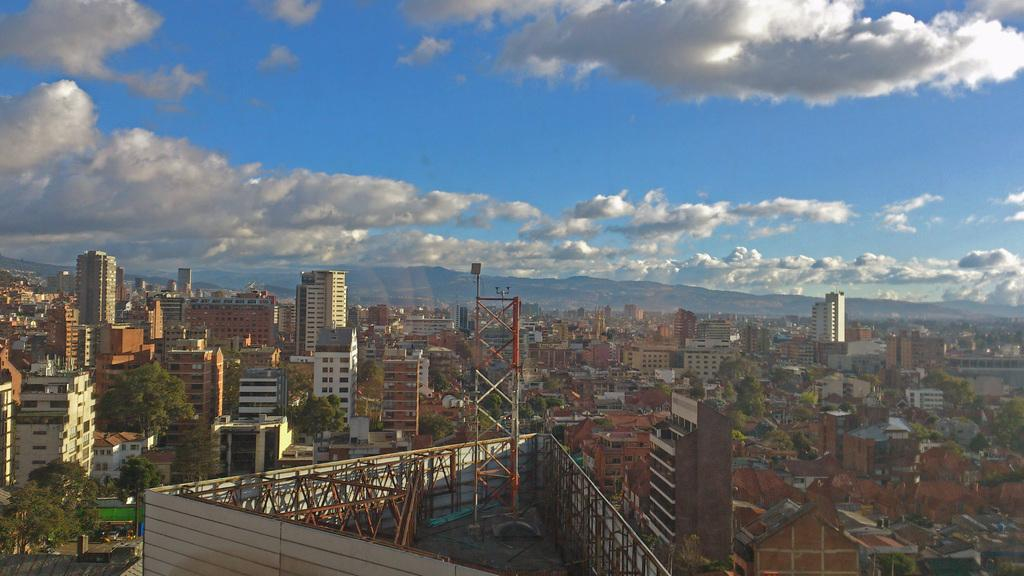What is the main structure in the image? There is a tower in the image. What type of objects are in the foreground? There are metal objects in the foreground. What can be seen on both sides of the tower? There are buildings on the left and right sides of the image. What type of vegetation is present in the image? There are trees on the left, right, and in the foreground. What is visible at the top of the image? The sky is visible at the top of the image. What is the cause of the headache experienced by the person in the image? There is no person present in the image, and therefore no headache or cause can be determined. 